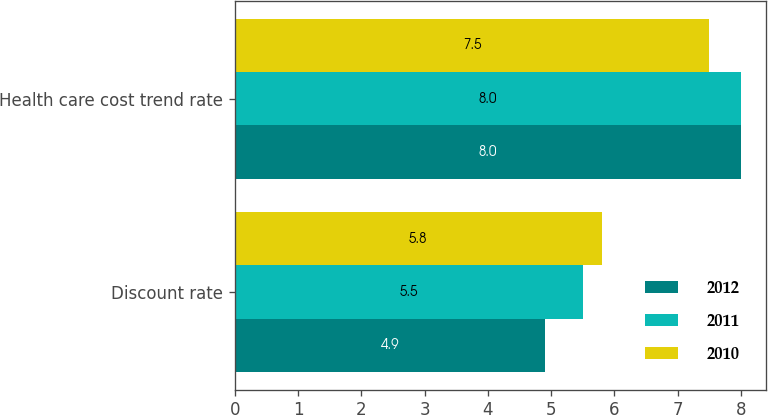Convert chart. <chart><loc_0><loc_0><loc_500><loc_500><stacked_bar_chart><ecel><fcel>Discount rate<fcel>Health care cost trend rate<nl><fcel>2012<fcel>4.9<fcel>8<nl><fcel>2011<fcel>5.5<fcel>8<nl><fcel>2010<fcel>5.8<fcel>7.5<nl></chart> 